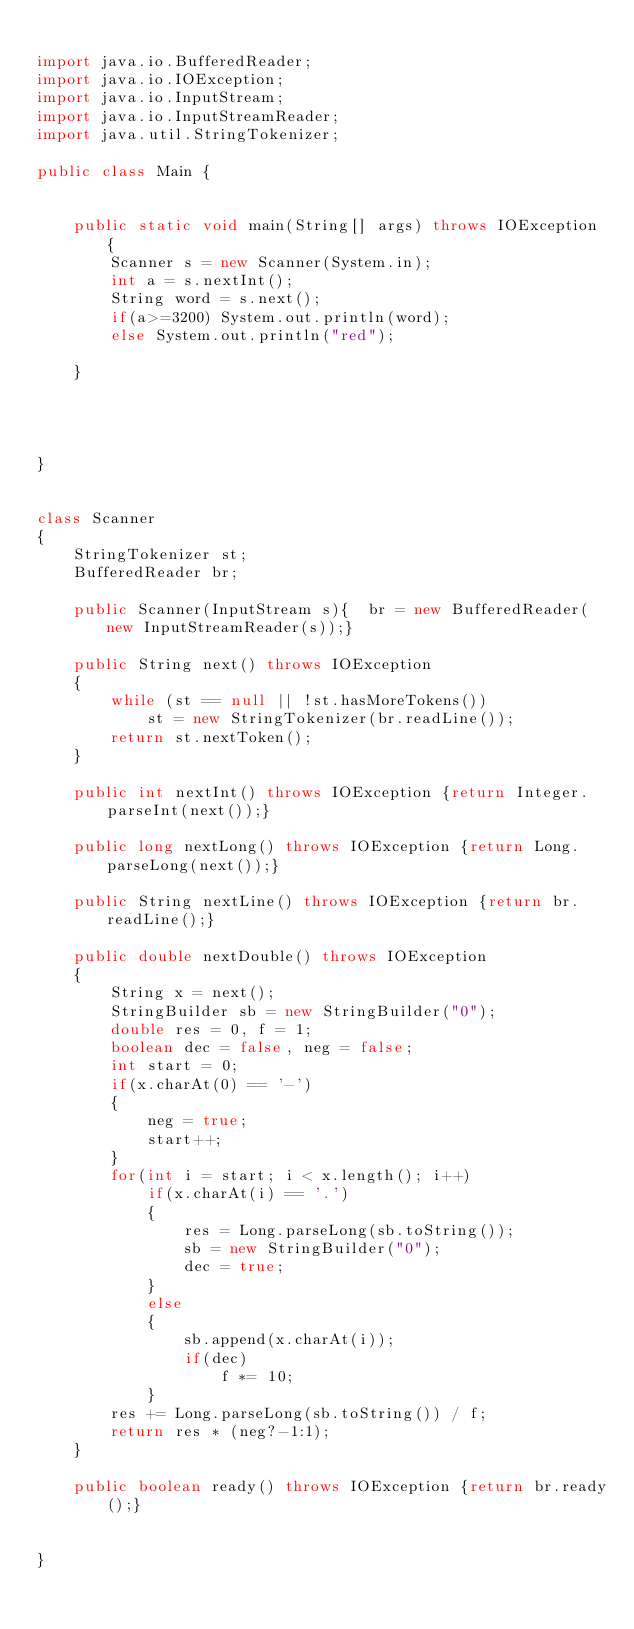Convert code to text. <code><loc_0><loc_0><loc_500><loc_500><_Java_>
import java.io.BufferedReader;
import java.io.IOException;
import java.io.InputStream;
import java.io.InputStreamReader;
import java.util.StringTokenizer;

public class Main {


    public static void main(String[] args) throws IOException {
        Scanner s = new Scanner(System.in);
        int a = s.nextInt();
        String word = s.next();
        if(a>=3200) System.out.println(word);
        else System.out.println("red");

    }




}


class Scanner
{
    StringTokenizer st;
    BufferedReader br;

    public Scanner(InputStream s){	br = new BufferedReader(new InputStreamReader(s));}

    public String next() throws IOException
    {
        while (st == null || !st.hasMoreTokens())
            st = new StringTokenizer(br.readLine());
        return st.nextToken();
    }

    public int nextInt() throws IOException {return Integer.parseInt(next());}

    public long nextLong() throws IOException {return Long.parseLong(next());}

    public String nextLine() throws IOException {return br.readLine();}

    public double nextDouble() throws IOException
    {
        String x = next();
        StringBuilder sb = new StringBuilder("0");
        double res = 0, f = 1;
        boolean dec = false, neg = false;
        int start = 0;
        if(x.charAt(0) == '-')
        {
            neg = true;
            start++;
        }
        for(int i = start; i < x.length(); i++)
            if(x.charAt(i) == '.')
            {
                res = Long.parseLong(sb.toString());
                sb = new StringBuilder("0");
                dec = true;
            }
            else
            {
                sb.append(x.charAt(i));
                if(dec)
                    f *= 10;
            }
        res += Long.parseLong(sb.toString()) / f;
        return res * (neg?-1:1);
    }

    public boolean ready() throws IOException {return br.ready();}


}</code> 